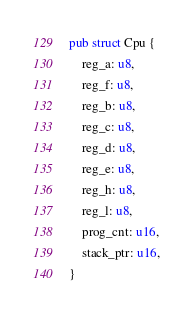Convert code to text. <code><loc_0><loc_0><loc_500><loc_500><_Rust_>pub struct Cpu {
    reg_a: u8,
    reg_f: u8,
    reg_b: u8,
    reg_c: u8,
    reg_d: u8,
    reg_e: u8,
    reg_h: u8,
    reg_l: u8,
    prog_cnt: u16,
    stack_ptr: u16,
}</code> 